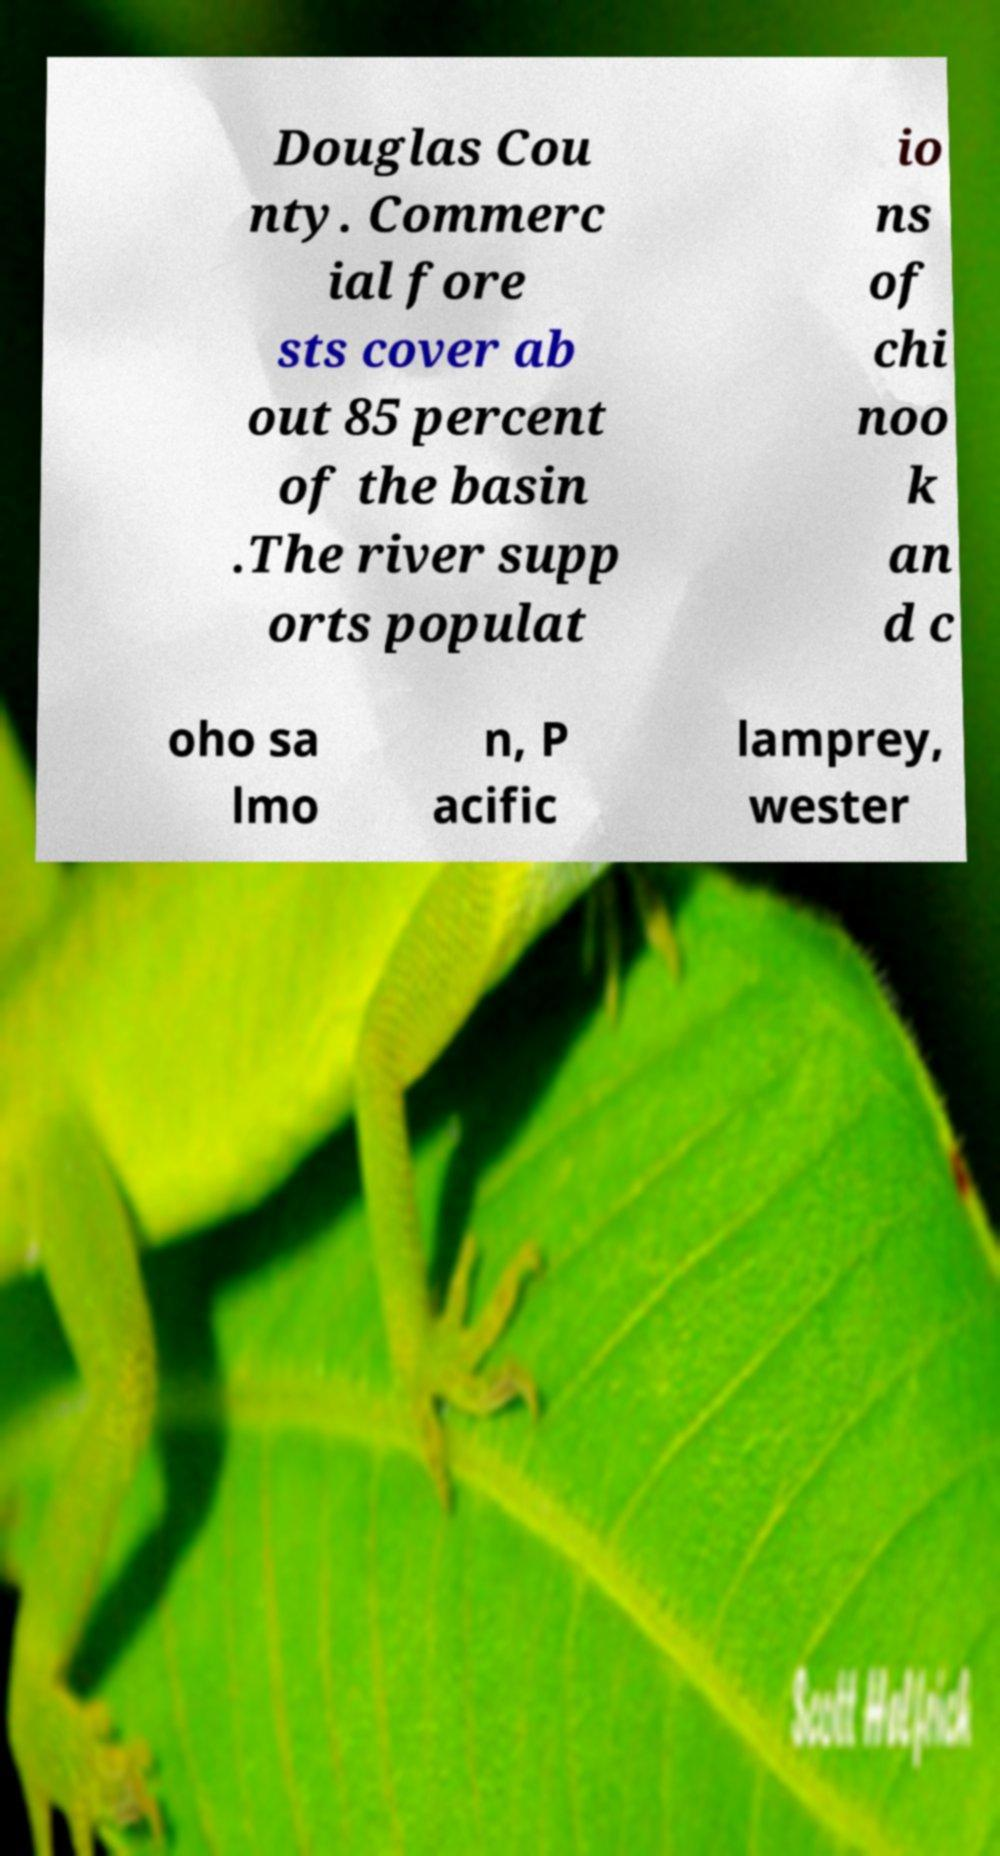Please read and relay the text visible in this image. What does it say? Douglas Cou nty. Commerc ial fore sts cover ab out 85 percent of the basin .The river supp orts populat io ns of chi noo k an d c oho sa lmo n, P acific lamprey, wester 